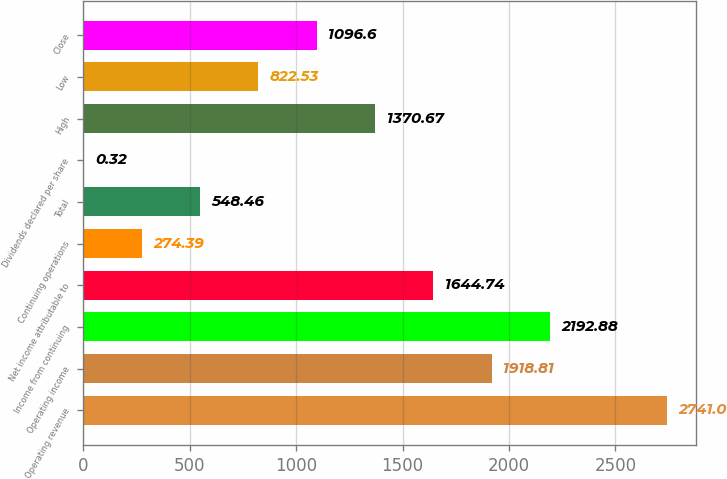<chart> <loc_0><loc_0><loc_500><loc_500><bar_chart><fcel>Operating revenue<fcel>Operating income<fcel>Income from continuing<fcel>Net income attributable to<fcel>Continuing operations<fcel>Total<fcel>Dividends declared per share<fcel>High<fcel>Low<fcel>Close<nl><fcel>2741<fcel>1918.81<fcel>2192.88<fcel>1644.74<fcel>274.39<fcel>548.46<fcel>0.32<fcel>1370.67<fcel>822.53<fcel>1096.6<nl></chart> 